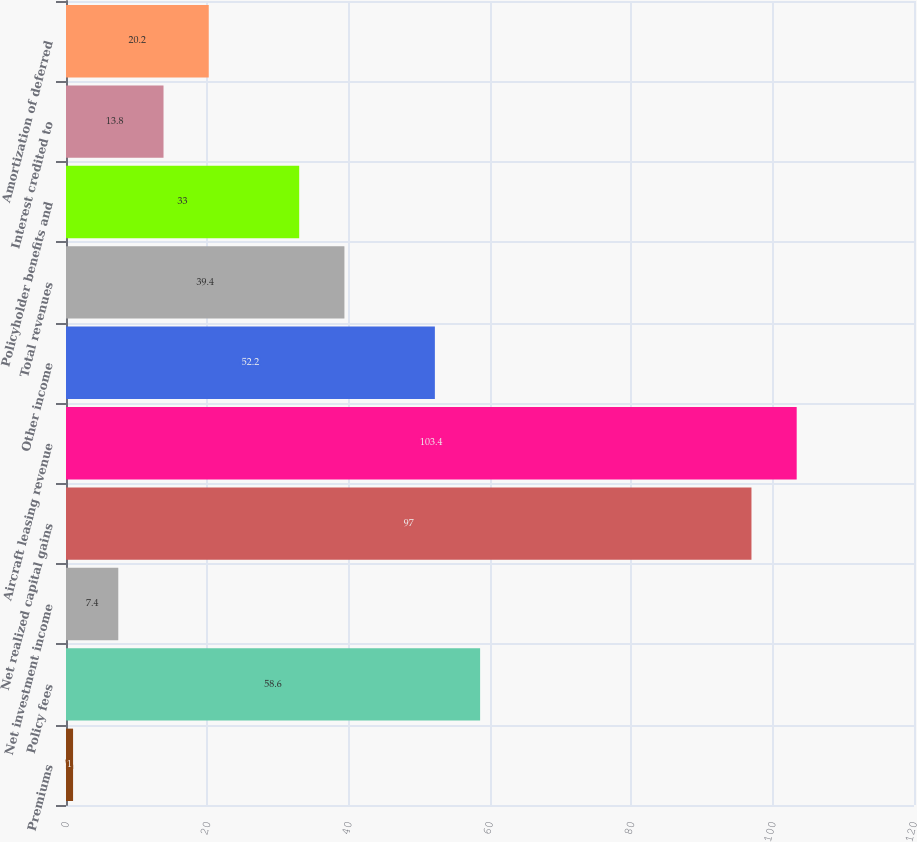<chart> <loc_0><loc_0><loc_500><loc_500><bar_chart><fcel>Premiums<fcel>Policy fees<fcel>Net investment income<fcel>Net realized capital gains<fcel>Aircraft leasing revenue<fcel>Other income<fcel>Total revenues<fcel>Policyholder benefits and<fcel>Interest credited to<fcel>Amortization of deferred<nl><fcel>1<fcel>58.6<fcel>7.4<fcel>97<fcel>103.4<fcel>52.2<fcel>39.4<fcel>33<fcel>13.8<fcel>20.2<nl></chart> 